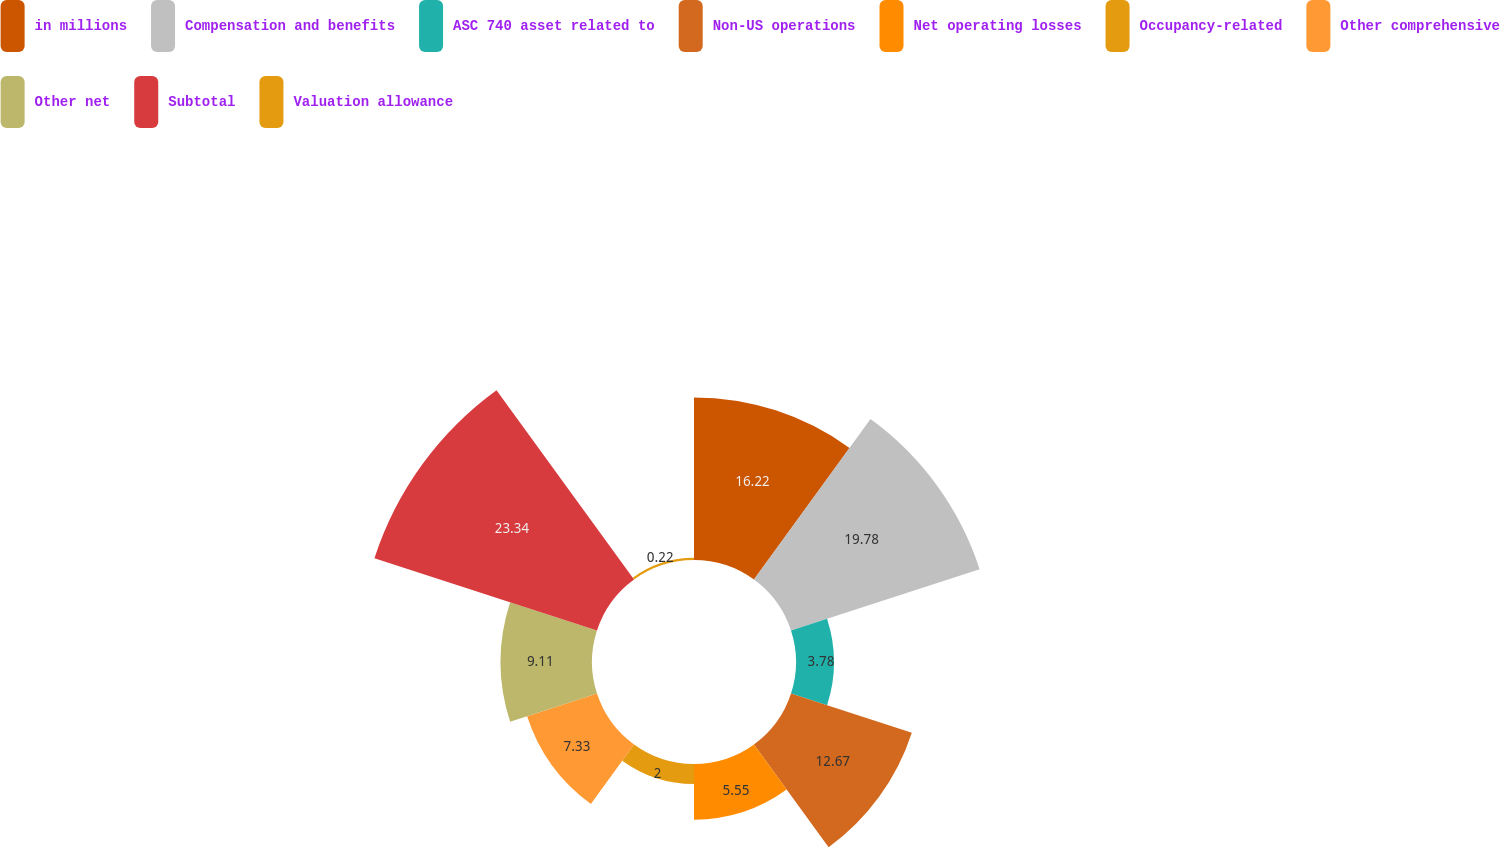Convert chart to OTSL. <chart><loc_0><loc_0><loc_500><loc_500><pie_chart><fcel>in millions<fcel>Compensation and benefits<fcel>ASC 740 asset related to<fcel>Non-US operations<fcel>Net operating losses<fcel>Occupancy-related<fcel>Other comprehensive<fcel>Other net<fcel>Subtotal<fcel>Valuation allowance<nl><fcel>16.22%<fcel>19.78%<fcel>3.78%<fcel>12.67%<fcel>5.55%<fcel>2.0%<fcel>7.33%<fcel>9.11%<fcel>23.34%<fcel>0.22%<nl></chart> 